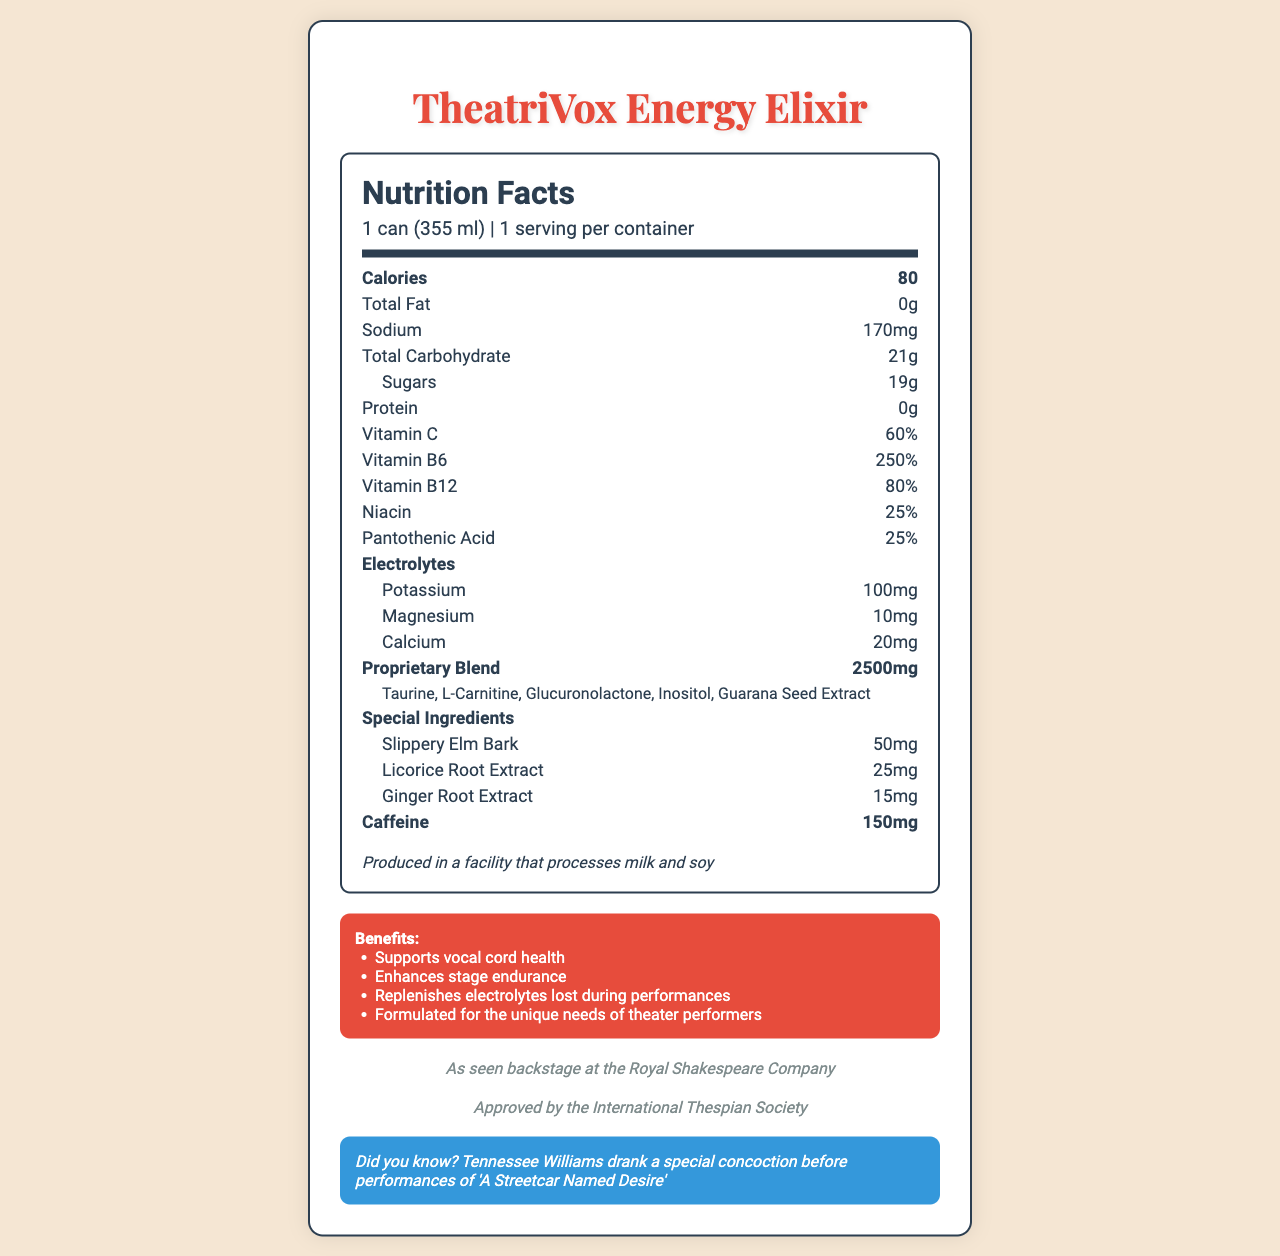What is the name of the energy drink? The name of the product is clearly labeled at the top of the document.
Answer: TheatriVox Energy Elixir What is the serving size for TheatriVox Energy Elixir? The serving size is mentioned right below the product name in the nutrition facts section.
Answer: 1 can (355 ml) How many calories are in one can of TheatriVox Energy Elixir? The number of calories per serving is listed as 80 in the nutrition facts section.
Answer: 80 What is the total amount of caffeine in one can? The total amount of caffeine is given in the nutrition facts label.
Answer: 150 mg Name three special ingredients included in TheatriVox Energy Elixir. The three special ingredients are listed under "Special Ingredients" in the nutrition facts section.
Answer: Slippery Elm Bark, Licorice Root Extract, Ginger Root Extract What is the total carbohydrate content per serving? A. 20g B. 21g C. 22g The nutrition facts label specifies the total carbohydrate content as 21 grams.
Answer: B Which organization has endorsed TheatriVox Energy Elixir? A. Royal Shakespeare Company B. International Thespian Society C. Broadway League The document mentions endorsements from both the Royal Shakespeare Company and the International Thespian Society.
Answer: A and B Is this product suitable for people with soy allergies? The allergen information indicates that the product is produced in a facility that processes soy.
Answer: No Summarize the main focus of the TheatriVox Energy Elixir's nutrition facts label. The label provides comprehensive information on nutritional content, special ingredients beneficial for vocal cords, marketing claims, and endorsements, specifically targeting the needs of theater performers.
Answer: The TheatriVox Energy Elixir's nutrition facts label emphasizes its benefits for theater performers, detailing calories, electrolytes, vitamins, special ingredients for vocal cord health, endorsements, and allergen information. Which playwright is mentioned in the trivia section? The trivia section mentions Tennessee Williams and his habit of drinking a special concoction before performances of 'A Streetcar Named Desire.'
Answer: Tennessee Williams What percentage of the daily value of Vitamin C does one serving contain? The nutrition facts section lists Vitamin C as 60% of the daily value.
Answer: 60% What kinds of stage benefits does the drink claim to offer? The marketing claims list these specific benefits.
Answer: Supports vocal cord health, enhances stage endurance, replenishes electrolytes lost during performances, formulated for the unique needs of theater performers What flavors are available for this energy drink? The document does not provide any information on the flavors available for TheatriVox Energy Elixir.
Answer: Not enough information 